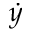<formula> <loc_0><loc_0><loc_500><loc_500>\dot { y }</formula> 